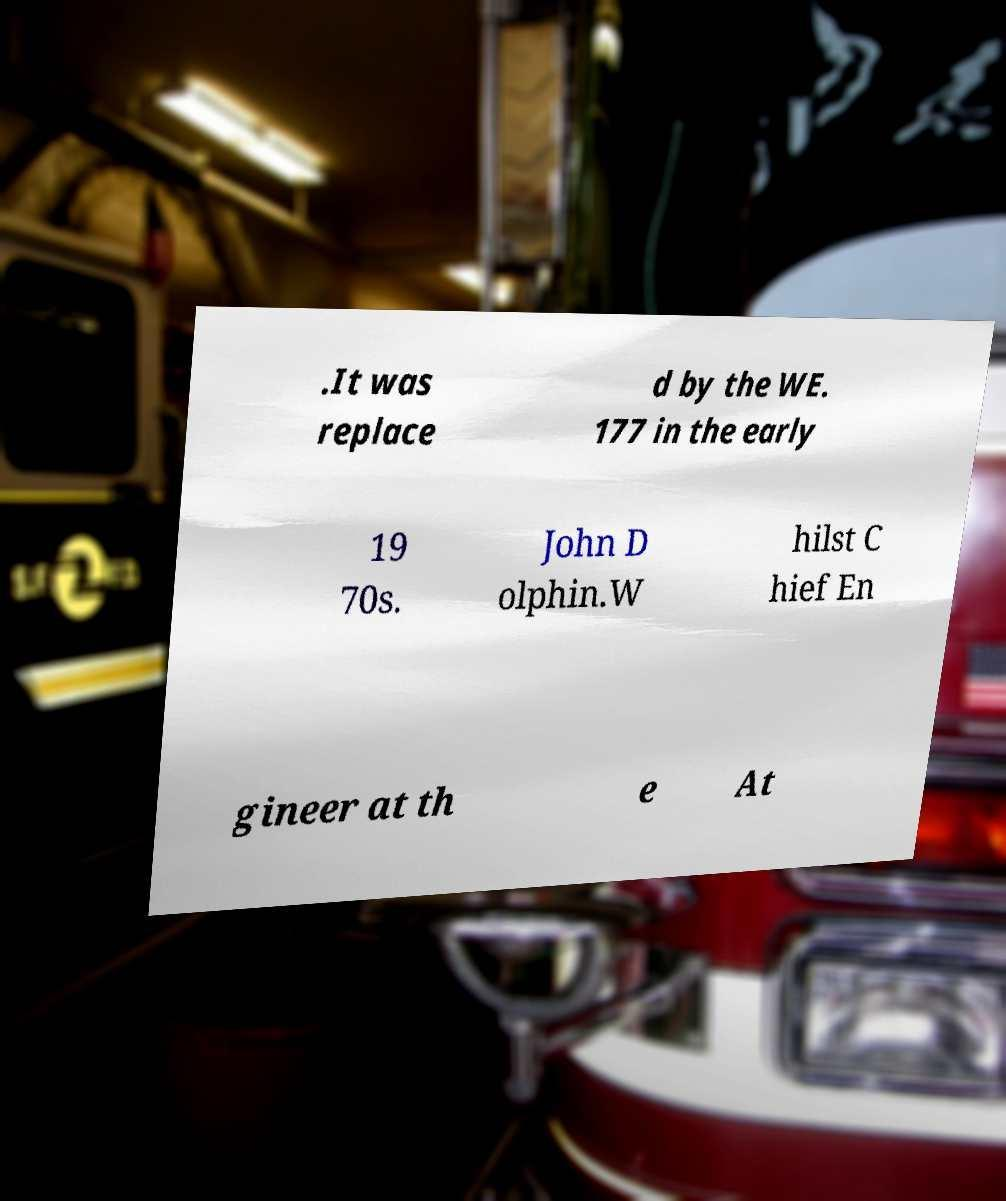Could you assist in decoding the text presented in this image and type it out clearly? .It was replace d by the WE. 177 in the early 19 70s. John D olphin.W hilst C hief En gineer at th e At 